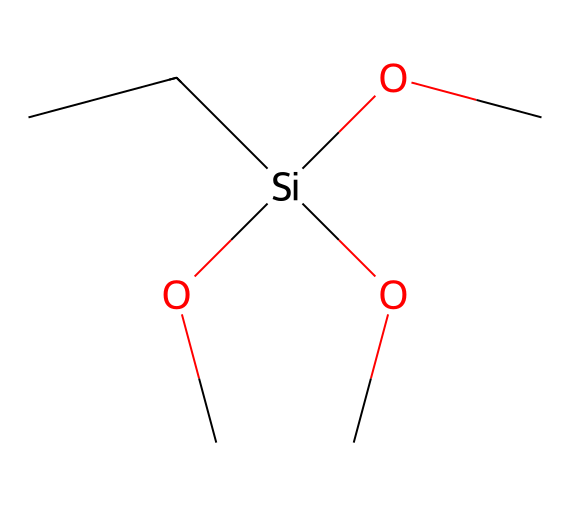What is the total number of carbon atoms in this silane structure? The SMILES representation shows "CC" at the beginning, indicating two carbon atoms from the chain, and three "OC" groups contribute one carbon each, totaling five carbon atoms.
Answer: five How many silicon atoms are present in the chemical? The SMILES representation includes "[Si]", indicating a single silicon atom is present in the structure.
Answer: one What is the degree of substitution for the silicon atom? The silicon atom is bonded to four groups: two alkyl (ethyl) groups and three alkoxy (methoxy) groups, indicating a tetrahedral configuration with four substituents.
Answer: four What type of functional groups are present in this compound? The compound contains both alkyl groups (from the ethyl components) and alkoxy groups (from the methoxy components), categorized as functional groups related to silanes.
Answer: alkyl and alkoxy How might this silane-based compound help with water repellency in firearm storage? The multiple alkoxy groups enable a strong hydrophobic character, contributing to water repellency on surfaces when applied, effectively protecting the stored firearms from moisture.
Answer: by providing hydrophobic properties Does this silane compound contain any elements other than carbon, silicon, and oxygen? The SMILES structure does not indicate the presence of any other elements; it only contains carbon (C), silicon (Si), and oxygen (O) atoms.
Answer: no 